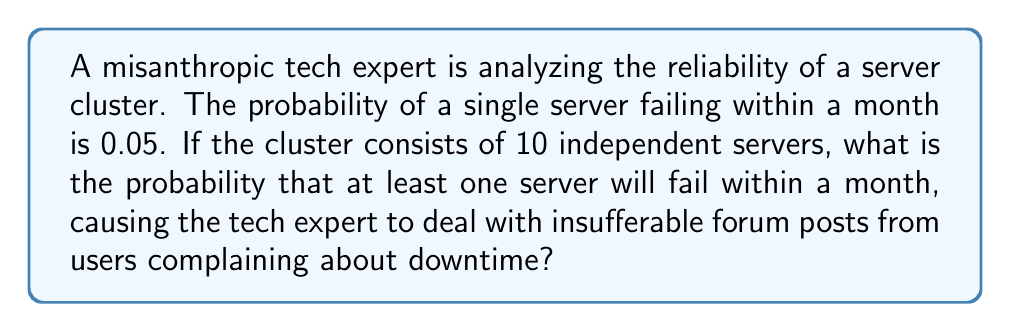Give your solution to this math problem. Let's approach this step-by-step:

1) First, let's consider the probability of a single server not failing:
   $P(\text{server not failing}) = 1 - P(\text{server failing}) = 1 - 0.05 = 0.95$

2) For the entire cluster to have no failures, all 10 servers must not fail. Since the servers are independent, we multiply the probabilities:
   $P(\text{no failures in cluster}) = 0.95^{10}$

3) We can calculate this:
   $0.95^{10} \approx 0.5987$

4) The probability of at least one failure is the complement of the probability of no failures:
   $P(\text{at least one failure}) = 1 - P(\text{no failures in cluster})$

5) Therefore:
   $P(\text{at least one failure}) = 1 - 0.5987 = 0.4013$

6) We can express this as a percentage:
   $0.4013 \times 100\% = 40.13\%$
Answer: 40.13% 